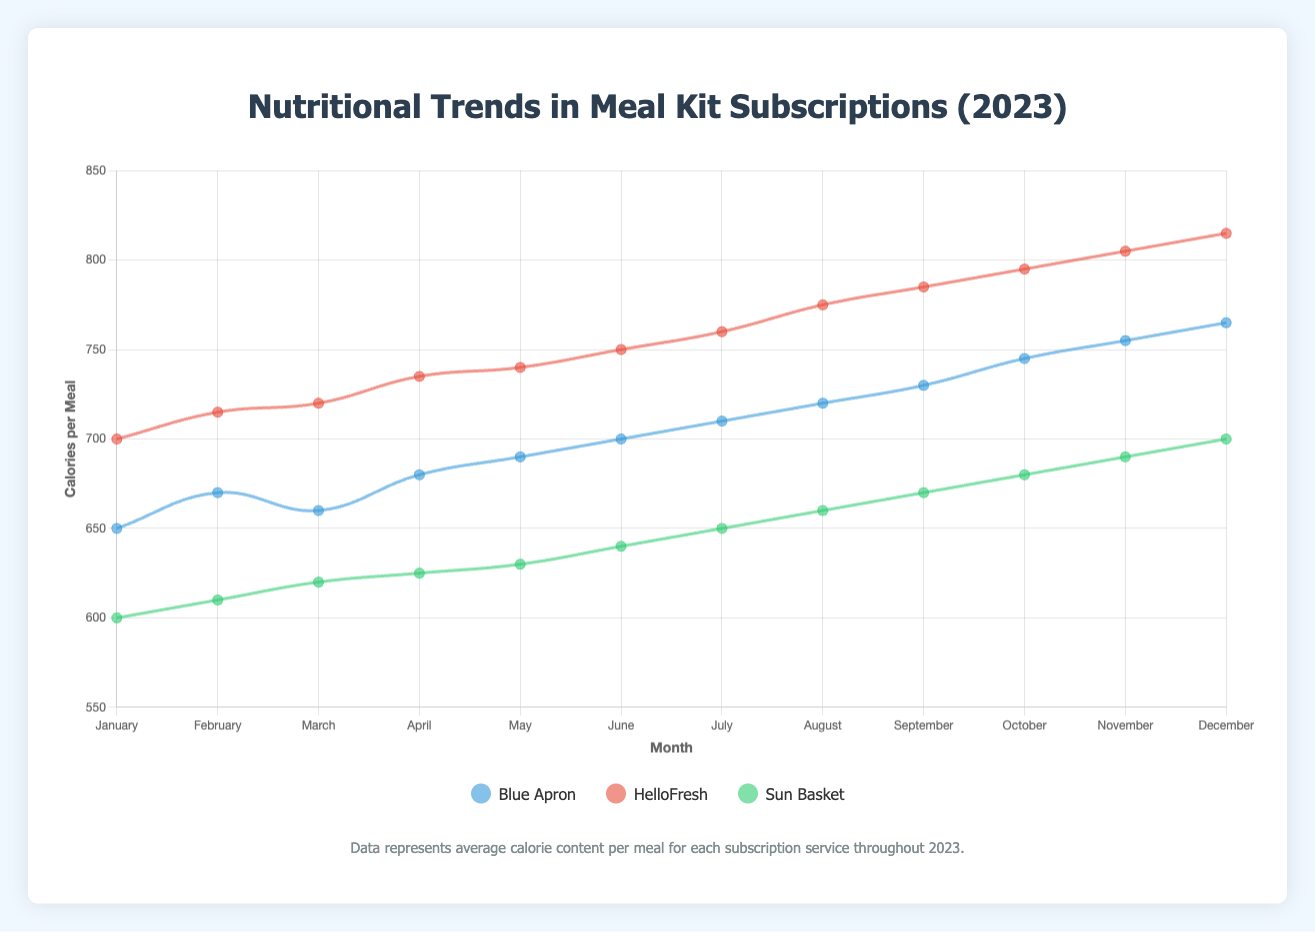Which company shows the highest increase in calories from January to December? To find the company with the highest increase in calories, calculate the difference between the December and January calorie values for each company: Blue Apron (765 - 650 = 115), HelloFresh (815 - 700 = 115), and Sun Basket (700 - 600 = 100). Both Blue Apron and HelloFresh have the highest increase in calories.
Answer: Blue Apron and HelloFresh Which month shows the highest average calorie content across all companies? Calculate the average calories for each month by summing up the calories for all companies and dividing by the number of companies: January ((650 + 700 + 600) / 3 = 650), February ((670 + 715 + 610) / 3 = 665), March ((660 + 720 + 620) / 3 = 666.67), April ((680 + 735 + 625) / 3 = 680), May ((690 + 740 + 630) / 3 = 686.67), June ((700 + 750 + 640) / 3 = 696.67), July ((710 + 760 + 650) / 3 = 706.67), August ((720 + 775 + 660) / 3 = 718.33), September ((730 + 785 + 670) / 3 = 728.33), October ((745 + 795 + 680) / 3 = 740), November ((755 + 805 + 690) / 3 = 750), December ((765 + 815 + 700) / 3 = 760). December shows the highest average calorie content.
Answer: December How many months did Sun Basket have the lowest calorie content among the three companies? Look at the calorie curves for each company month by month and compare the values. Sun Basket has the lowest calorie content in January, February, March, April, May, June, July, August, September, October, November, and December. Count the number of months: 12 months.
Answer: 12 What is the average calorie content for Blue Apron over the entire year? Sum up the monthly calorie values for Blue Apron and divide by the number of months: (650 + 670 + 660 + 680 + 690 + 700 + 710 + 720 + 730 + 745 + 755 + 765) / 12 = 7895 / 12 = 657.92.
Answer: 657.92 During which month did HelloFresh and Blue Apron have the same calorie content? Compare the calorie values of HelloFresh and Blue Apron month by month. There is no month where HelloFresh and Blue Apron have the same calorie content.
Answer: None Which company had the most consistent calorie content throughout the year (least variation)? Calculate the variation (difference between the highest and lowest calorie values) for each company. Blue Apron: 765 - 650 = 115, HelloFresh: 815 - 700 = 115, Sun Basket: 700 - 600 = 100. Sun Basket had the least variation in calorie content.
Answer: Sun Basket How many months did Blue Apron's calorie content increase compared to the previous month? Check the calorie values for Blue Apron month by month and count the number of increases: January to February (650 to 670, increase), February to March (670 to 660, decrease), March to April (660 to 680, increase), April to May (680 to 690, increase), May to June (690 to 700, increase), June to July (700 to 710, increase), July to August (710 to 720, increase), August to September (720 to 730, increase), September to October (730 to 745, increase), October to November (745 to 755, increase), November to December (755 to 765, increase). Blue Apron's calorie content increased in 9 months.
Answer: 9 What is the sum of the calorie values for Sun Basket in the first quarter (January to March)? Sum up the calorie values for Sun Basket for the months January, February, and March: (600 + 610 + 620) = 1830.
Answer: 1830 